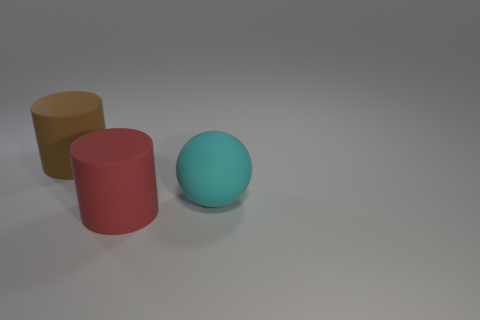Subtract all red cylinders. How many cylinders are left? 1 Add 2 rubber cylinders. How many objects exist? 5 Subtract all cylinders. How many objects are left? 1 Subtract 1 balls. How many balls are left? 0 Subtract all blue blocks. How many blue cylinders are left? 0 Subtract all red rubber cylinders. Subtract all large metal cylinders. How many objects are left? 2 Add 1 cyan spheres. How many cyan spheres are left? 2 Add 3 metallic things. How many metallic things exist? 3 Subtract 0 blue blocks. How many objects are left? 3 Subtract all gray spheres. Subtract all purple cylinders. How many spheres are left? 1 